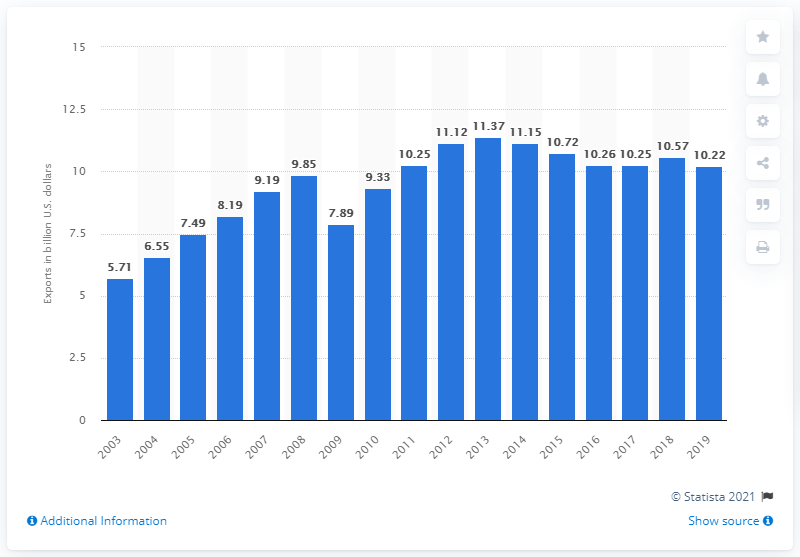Draw attention to some important aspects in this diagram. From 2003 to 2019, the export value of photo and service industry machinery was 10.22 million dollars. 